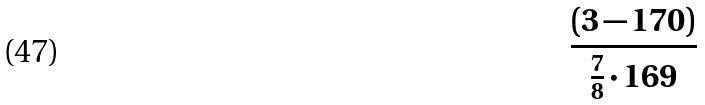Convert formula to latex. <formula><loc_0><loc_0><loc_500><loc_500>\frac { ( 3 - 1 7 0 ) } { \frac { 7 } { 8 } \cdot 1 6 9 }</formula> 